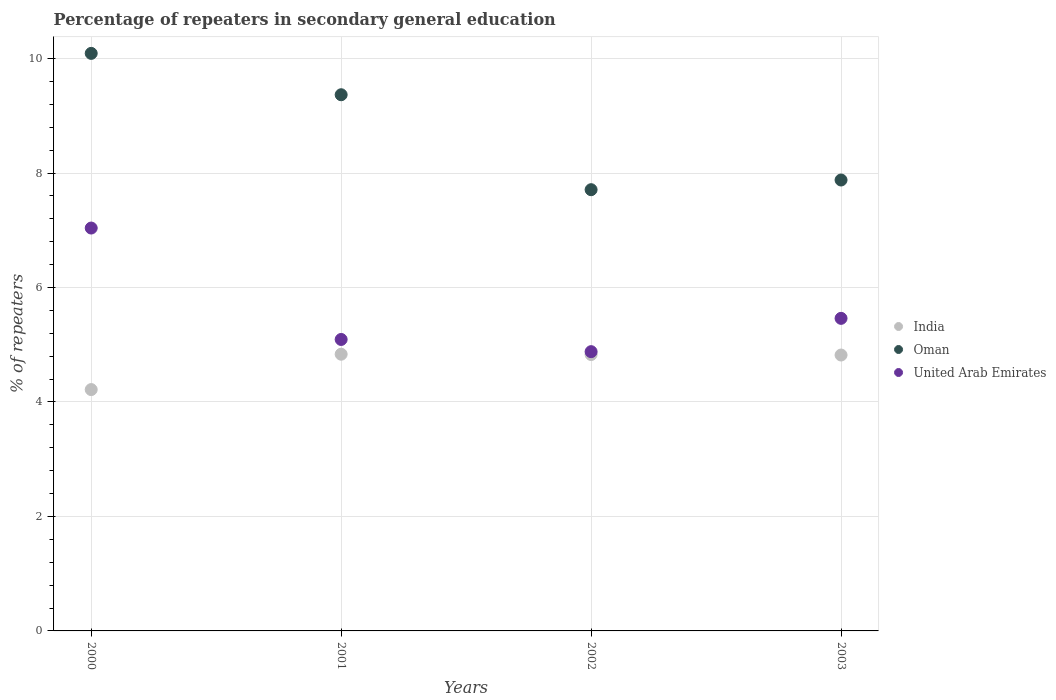How many different coloured dotlines are there?
Your answer should be compact. 3. Is the number of dotlines equal to the number of legend labels?
Keep it short and to the point. Yes. What is the percentage of repeaters in secondary general education in India in 2002?
Your answer should be compact. 4.83. Across all years, what is the maximum percentage of repeaters in secondary general education in United Arab Emirates?
Provide a short and direct response. 7.04. Across all years, what is the minimum percentage of repeaters in secondary general education in United Arab Emirates?
Keep it short and to the point. 4.88. What is the total percentage of repeaters in secondary general education in United Arab Emirates in the graph?
Give a very brief answer. 22.47. What is the difference between the percentage of repeaters in secondary general education in Oman in 2001 and that in 2002?
Your answer should be very brief. 1.66. What is the difference between the percentage of repeaters in secondary general education in Oman in 2003 and the percentage of repeaters in secondary general education in India in 2001?
Your answer should be compact. 3.04. What is the average percentage of repeaters in secondary general education in India per year?
Your response must be concise. 4.68. In the year 2001, what is the difference between the percentage of repeaters in secondary general education in Oman and percentage of repeaters in secondary general education in United Arab Emirates?
Offer a very short reply. 4.28. What is the ratio of the percentage of repeaters in secondary general education in India in 2000 to that in 2003?
Offer a terse response. 0.87. Is the percentage of repeaters in secondary general education in Oman in 2001 less than that in 2003?
Provide a short and direct response. No. What is the difference between the highest and the second highest percentage of repeaters in secondary general education in United Arab Emirates?
Offer a very short reply. 1.58. What is the difference between the highest and the lowest percentage of repeaters in secondary general education in United Arab Emirates?
Give a very brief answer. 2.16. In how many years, is the percentage of repeaters in secondary general education in Oman greater than the average percentage of repeaters in secondary general education in Oman taken over all years?
Your answer should be compact. 2. Does the percentage of repeaters in secondary general education in Oman monotonically increase over the years?
Provide a succinct answer. No. Is the percentage of repeaters in secondary general education in United Arab Emirates strictly greater than the percentage of repeaters in secondary general education in India over the years?
Ensure brevity in your answer.  Yes. Does the graph contain any zero values?
Your answer should be compact. No. Does the graph contain grids?
Offer a terse response. Yes. Where does the legend appear in the graph?
Offer a very short reply. Center right. How are the legend labels stacked?
Provide a succinct answer. Vertical. What is the title of the graph?
Provide a succinct answer. Percentage of repeaters in secondary general education. Does "Georgia" appear as one of the legend labels in the graph?
Make the answer very short. No. What is the label or title of the Y-axis?
Provide a succinct answer. % of repeaters. What is the % of repeaters in India in 2000?
Offer a very short reply. 4.22. What is the % of repeaters of Oman in 2000?
Your answer should be compact. 10.09. What is the % of repeaters in United Arab Emirates in 2000?
Offer a very short reply. 7.04. What is the % of repeaters of India in 2001?
Make the answer very short. 4.83. What is the % of repeaters in Oman in 2001?
Your answer should be very brief. 9.37. What is the % of repeaters of United Arab Emirates in 2001?
Make the answer very short. 5.09. What is the % of repeaters of India in 2002?
Provide a short and direct response. 4.83. What is the % of repeaters of Oman in 2002?
Your answer should be very brief. 7.71. What is the % of repeaters of United Arab Emirates in 2002?
Offer a terse response. 4.88. What is the % of repeaters in India in 2003?
Your answer should be very brief. 4.82. What is the % of repeaters in Oman in 2003?
Your answer should be very brief. 7.88. What is the % of repeaters in United Arab Emirates in 2003?
Your response must be concise. 5.46. Across all years, what is the maximum % of repeaters of India?
Your response must be concise. 4.83. Across all years, what is the maximum % of repeaters of Oman?
Provide a succinct answer. 10.09. Across all years, what is the maximum % of repeaters in United Arab Emirates?
Provide a succinct answer. 7.04. Across all years, what is the minimum % of repeaters of India?
Your response must be concise. 4.22. Across all years, what is the minimum % of repeaters of Oman?
Give a very brief answer. 7.71. Across all years, what is the minimum % of repeaters of United Arab Emirates?
Offer a very short reply. 4.88. What is the total % of repeaters of India in the graph?
Provide a succinct answer. 18.7. What is the total % of repeaters of Oman in the graph?
Ensure brevity in your answer.  35.05. What is the total % of repeaters of United Arab Emirates in the graph?
Offer a very short reply. 22.47. What is the difference between the % of repeaters in India in 2000 and that in 2001?
Provide a short and direct response. -0.62. What is the difference between the % of repeaters in Oman in 2000 and that in 2001?
Provide a succinct answer. 0.72. What is the difference between the % of repeaters of United Arab Emirates in 2000 and that in 2001?
Keep it short and to the point. 1.95. What is the difference between the % of repeaters of India in 2000 and that in 2002?
Keep it short and to the point. -0.61. What is the difference between the % of repeaters in Oman in 2000 and that in 2002?
Provide a succinct answer. 2.38. What is the difference between the % of repeaters of United Arab Emirates in 2000 and that in 2002?
Keep it short and to the point. 2.16. What is the difference between the % of repeaters of India in 2000 and that in 2003?
Provide a succinct answer. -0.6. What is the difference between the % of repeaters of Oman in 2000 and that in 2003?
Your response must be concise. 2.21. What is the difference between the % of repeaters in United Arab Emirates in 2000 and that in 2003?
Make the answer very short. 1.58. What is the difference between the % of repeaters of India in 2001 and that in 2002?
Offer a terse response. 0.01. What is the difference between the % of repeaters of Oman in 2001 and that in 2002?
Offer a terse response. 1.66. What is the difference between the % of repeaters in United Arab Emirates in 2001 and that in 2002?
Offer a very short reply. 0.21. What is the difference between the % of repeaters of India in 2001 and that in 2003?
Your answer should be very brief. 0.01. What is the difference between the % of repeaters of Oman in 2001 and that in 2003?
Offer a very short reply. 1.49. What is the difference between the % of repeaters of United Arab Emirates in 2001 and that in 2003?
Your answer should be very brief. -0.37. What is the difference between the % of repeaters in India in 2002 and that in 2003?
Offer a very short reply. 0.01. What is the difference between the % of repeaters in Oman in 2002 and that in 2003?
Provide a succinct answer. -0.17. What is the difference between the % of repeaters of United Arab Emirates in 2002 and that in 2003?
Provide a succinct answer. -0.58. What is the difference between the % of repeaters of India in 2000 and the % of repeaters of Oman in 2001?
Ensure brevity in your answer.  -5.15. What is the difference between the % of repeaters of India in 2000 and the % of repeaters of United Arab Emirates in 2001?
Your answer should be compact. -0.88. What is the difference between the % of repeaters of Oman in 2000 and the % of repeaters of United Arab Emirates in 2001?
Provide a short and direct response. 5. What is the difference between the % of repeaters of India in 2000 and the % of repeaters of Oman in 2002?
Make the answer very short. -3.49. What is the difference between the % of repeaters in India in 2000 and the % of repeaters in United Arab Emirates in 2002?
Your answer should be very brief. -0.66. What is the difference between the % of repeaters of Oman in 2000 and the % of repeaters of United Arab Emirates in 2002?
Offer a terse response. 5.21. What is the difference between the % of repeaters in India in 2000 and the % of repeaters in Oman in 2003?
Your answer should be compact. -3.66. What is the difference between the % of repeaters of India in 2000 and the % of repeaters of United Arab Emirates in 2003?
Your answer should be compact. -1.24. What is the difference between the % of repeaters in Oman in 2000 and the % of repeaters in United Arab Emirates in 2003?
Ensure brevity in your answer.  4.63. What is the difference between the % of repeaters of India in 2001 and the % of repeaters of Oman in 2002?
Keep it short and to the point. -2.87. What is the difference between the % of repeaters of India in 2001 and the % of repeaters of United Arab Emirates in 2002?
Your response must be concise. -0.04. What is the difference between the % of repeaters of Oman in 2001 and the % of repeaters of United Arab Emirates in 2002?
Offer a very short reply. 4.49. What is the difference between the % of repeaters of India in 2001 and the % of repeaters of Oman in 2003?
Keep it short and to the point. -3.04. What is the difference between the % of repeaters in India in 2001 and the % of repeaters in United Arab Emirates in 2003?
Your answer should be very brief. -0.63. What is the difference between the % of repeaters in Oman in 2001 and the % of repeaters in United Arab Emirates in 2003?
Your answer should be very brief. 3.91. What is the difference between the % of repeaters in India in 2002 and the % of repeaters in Oman in 2003?
Offer a very short reply. -3.05. What is the difference between the % of repeaters of India in 2002 and the % of repeaters of United Arab Emirates in 2003?
Keep it short and to the point. -0.63. What is the difference between the % of repeaters in Oman in 2002 and the % of repeaters in United Arab Emirates in 2003?
Provide a succinct answer. 2.25. What is the average % of repeaters in India per year?
Your answer should be compact. 4.68. What is the average % of repeaters of Oman per year?
Ensure brevity in your answer.  8.76. What is the average % of repeaters of United Arab Emirates per year?
Offer a very short reply. 5.62. In the year 2000, what is the difference between the % of repeaters in India and % of repeaters in Oman?
Keep it short and to the point. -5.87. In the year 2000, what is the difference between the % of repeaters in India and % of repeaters in United Arab Emirates?
Ensure brevity in your answer.  -2.82. In the year 2000, what is the difference between the % of repeaters in Oman and % of repeaters in United Arab Emirates?
Offer a very short reply. 3.05. In the year 2001, what is the difference between the % of repeaters of India and % of repeaters of Oman?
Ensure brevity in your answer.  -4.53. In the year 2001, what is the difference between the % of repeaters in India and % of repeaters in United Arab Emirates?
Provide a short and direct response. -0.26. In the year 2001, what is the difference between the % of repeaters of Oman and % of repeaters of United Arab Emirates?
Offer a very short reply. 4.28. In the year 2002, what is the difference between the % of repeaters in India and % of repeaters in Oman?
Provide a succinct answer. -2.88. In the year 2002, what is the difference between the % of repeaters in India and % of repeaters in United Arab Emirates?
Keep it short and to the point. -0.05. In the year 2002, what is the difference between the % of repeaters in Oman and % of repeaters in United Arab Emirates?
Provide a short and direct response. 2.83. In the year 2003, what is the difference between the % of repeaters of India and % of repeaters of Oman?
Your answer should be very brief. -3.06. In the year 2003, what is the difference between the % of repeaters in India and % of repeaters in United Arab Emirates?
Provide a short and direct response. -0.64. In the year 2003, what is the difference between the % of repeaters in Oman and % of repeaters in United Arab Emirates?
Provide a succinct answer. 2.42. What is the ratio of the % of repeaters of India in 2000 to that in 2001?
Your answer should be compact. 0.87. What is the ratio of the % of repeaters of Oman in 2000 to that in 2001?
Keep it short and to the point. 1.08. What is the ratio of the % of repeaters in United Arab Emirates in 2000 to that in 2001?
Ensure brevity in your answer.  1.38. What is the ratio of the % of repeaters in India in 2000 to that in 2002?
Make the answer very short. 0.87. What is the ratio of the % of repeaters of Oman in 2000 to that in 2002?
Your answer should be compact. 1.31. What is the ratio of the % of repeaters of United Arab Emirates in 2000 to that in 2002?
Offer a very short reply. 1.44. What is the ratio of the % of repeaters in India in 2000 to that in 2003?
Provide a succinct answer. 0.87. What is the ratio of the % of repeaters in Oman in 2000 to that in 2003?
Ensure brevity in your answer.  1.28. What is the ratio of the % of repeaters of United Arab Emirates in 2000 to that in 2003?
Ensure brevity in your answer.  1.29. What is the ratio of the % of repeaters of Oman in 2001 to that in 2002?
Your answer should be very brief. 1.22. What is the ratio of the % of repeaters of United Arab Emirates in 2001 to that in 2002?
Keep it short and to the point. 1.04. What is the ratio of the % of repeaters in Oman in 2001 to that in 2003?
Offer a very short reply. 1.19. What is the ratio of the % of repeaters of United Arab Emirates in 2001 to that in 2003?
Your answer should be compact. 0.93. What is the ratio of the % of repeaters in Oman in 2002 to that in 2003?
Your response must be concise. 0.98. What is the ratio of the % of repeaters in United Arab Emirates in 2002 to that in 2003?
Provide a short and direct response. 0.89. What is the difference between the highest and the second highest % of repeaters of India?
Your response must be concise. 0.01. What is the difference between the highest and the second highest % of repeaters of Oman?
Offer a very short reply. 0.72. What is the difference between the highest and the second highest % of repeaters in United Arab Emirates?
Your answer should be very brief. 1.58. What is the difference between the highest and the lowest % of repeaters in India?
Offer a very short reply. 0.62. What is the difference between the highest and the lowest % of repeaters of Oman?
Provide a short and direct response. 2.38. What is the difference between the highest and the lowest % of repeaters of United Arab Emirates?
Provide a short and direct response. 2.16. 